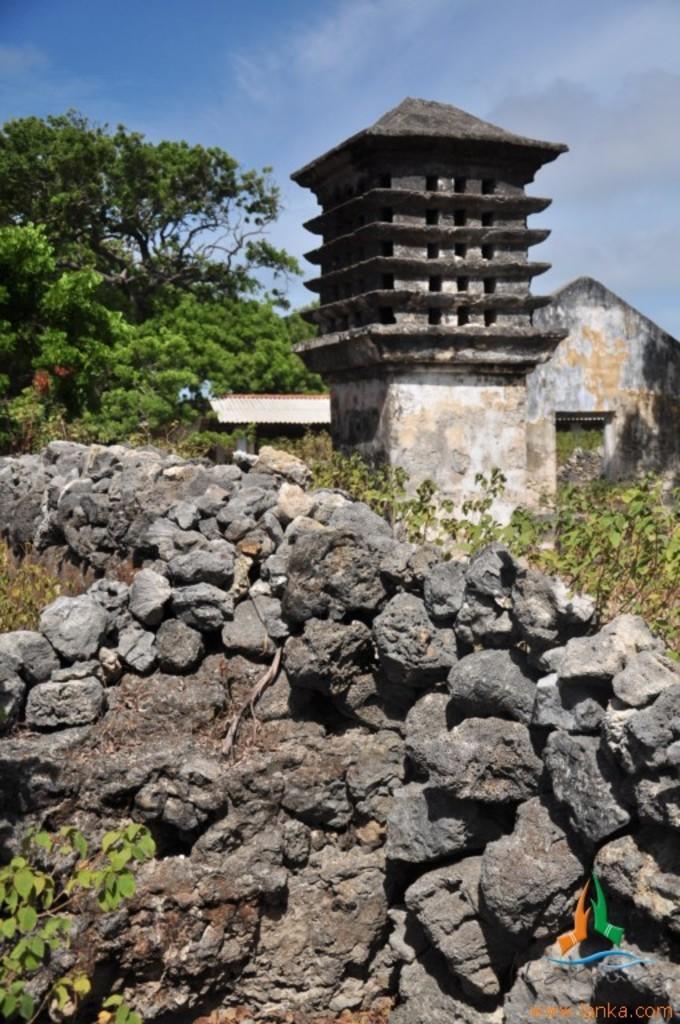Describe this image in one or two sentences. In this image, we can see trees, rocks, sheds, an architecture, some plants. At the top, there are clouds in the sky and at the bottom, we can see some text and a logo. 